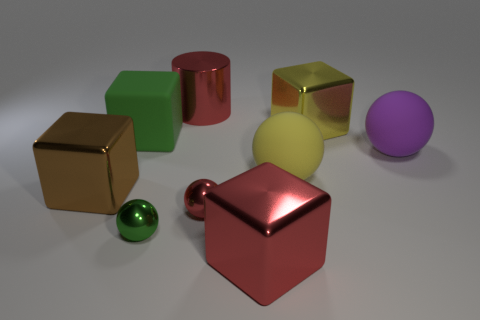What material is the green thing that is in front of the metallic cube that is on the left side of the green block?
Offer a terse response. Metal. Are there any other things that are the same size as the brown object?
Offer a very short reply. Yes. Do the large brown object and the red thing in front of the tiny red ball have the same material?
Your response must be concise. Yes. What is the material of the object that is in front of the purple rubber thing and to the left of the small green shiny ball?
Provide a succinct answer. Metal. The metallic cube that is in front of the brown metal block that is in front of the green rubber thing is what color?
Offer a very short reply. Red. There is a large red object behind the large red metal block; what is its material?
Your answer should be very brief. Metal. Is the number of red spheres less than the number of big gray metallic cubes?
Ensure brevity in your answer.  No. Does the large green rubber thing have the same shape as the red object behind the green block?
Your answer should be very brief. No. There is a matte object that is behind the yellow rubber object and to the right of the green ball; what shape is it?
Your answer should be compact. Sphere. Are there an equal number of big red metallic blocks that are left of the tiny green thing and small objects right of the large purple rubber object?
Provide a short and direct response. Yes. 